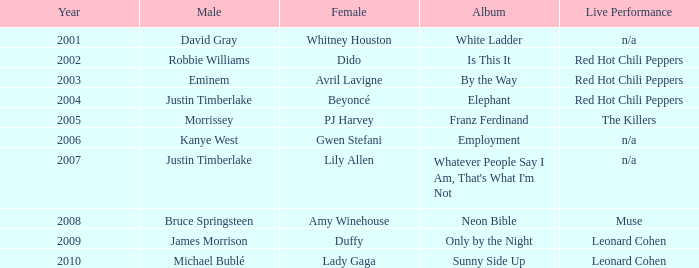Which male is paired with dido in 2004? Robbie Williams. 